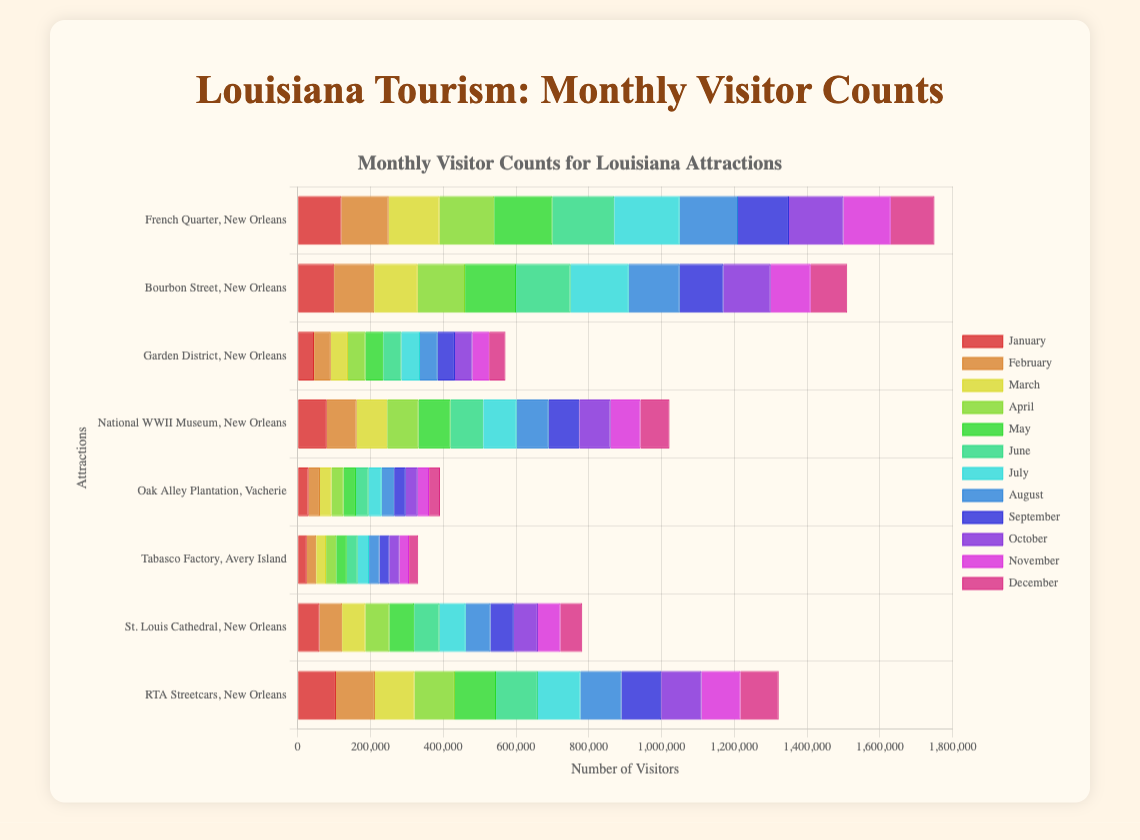Which attraction had the highest visitor count in July? First, look for the bar with the highest value in July. Count all the bars under July, and you can see that “French Quarter, New Orleans” has the highest visitor count.
Answer: French Quarter, New Orleans Which attraction had more visitors in April: Oak Alley Plantation or Tabasco Factory? Compare the heights of the bars for April corresponding to Oak Alley Plantation and Tabasco Factory. Oak Alley Plantation had a higher bar for April.
Answer: Oak Alley Plantation Which month had the highest visitor count for RTA Streetcars? Look for RTA Streetcars in the dataset, then compare the heights of the bars for all months. The tallest bar is in July.
Answer: July What's the total number of tourists in June for French Quarter, Bourbon Street, and Garden District? Sum the visitor counts for June for these three attractions: 170000 (French Quarter) + 150000 (Bourbon Street) + 50000 (Garden District). The total is 370000.
Answer: 370000 What is the average number of visitors in August for all the attractions? Sum the visitor counts for all attractions in August, then divide by the number of attractions (8): (160000 + 140000 + 49000 + 88000 + 34000 + 29000 + 68000 + 113000) / 8 = 6776250 / 8. The average is 84750.
Answer: 84750 Does St. Louis Cathedral have more visitors in December or January? Compare the bar heights for St. Louis Cathedral in December and January. Both months have the same visitor count of 60,000.
Answer: They are equal Which attraction experienced the least variation in monthly visitor counts? Look for the bars with the most consistent height across different months. The Garden District has very consistent bar heights.
Answer: Garden District Which two attractions have similar visitor counts in March? Compare the bar heights for all attractions in March. The "Garden District" and "Oak Alley Plantation" have visitor counts that are close (47000 and 32000). This indicates that "National WWII Museum, New Orleans" (84000) and "RTA Streetcars, New Orleans" (109000) have similar heights.
Answer: National WWII Museum, New Orleans and RTA Streetcars, New Orleans 